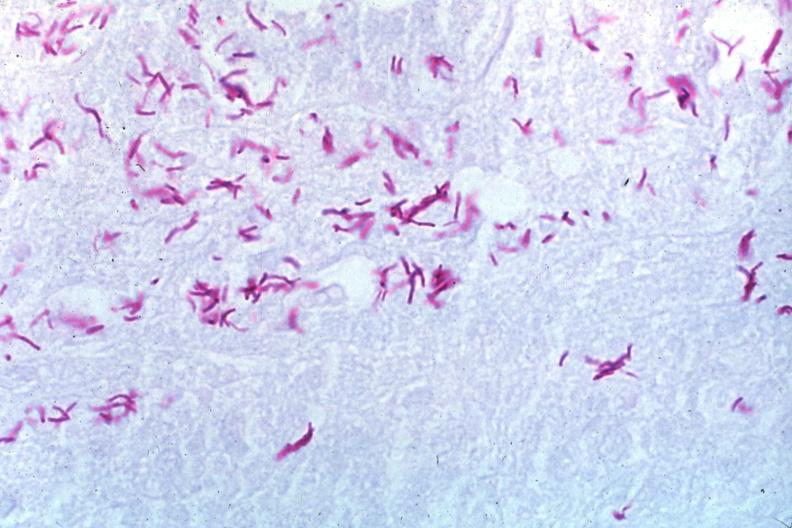s lymph node present?
Answer the question using a single word or phrase. Yes 